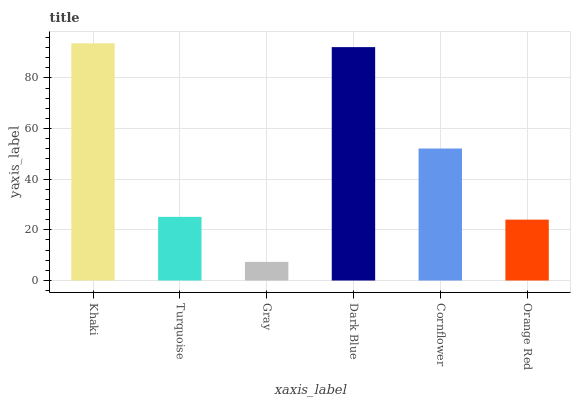Is Gray the minimum?
Answer yes or no. Yes. Is Khaki the maximum?
Answer yes or no. Yes. Is Turquoise the minimum?
Answer yes or no. No. Is Turquoise the maximum?
Answer yes or no. No. Is Khaki greater than Turquoise?
Answer yes or no. Yes. Is Turquoise less than Khaki?
Answer yes or no. Yes. Is Turquoise greater than Khaki?
Answer yes or no. No. Is Khaki less than Turquoise?
Answer yes or no. No. Is Cornflower the high median?
Answer yes or no. Yes. Is Turquoise the low median?
Answer yes or no. Yes. Is Khaki the high median?
Answer yes or no. No. Is Gray the low median?
Answer yes or no. No. 